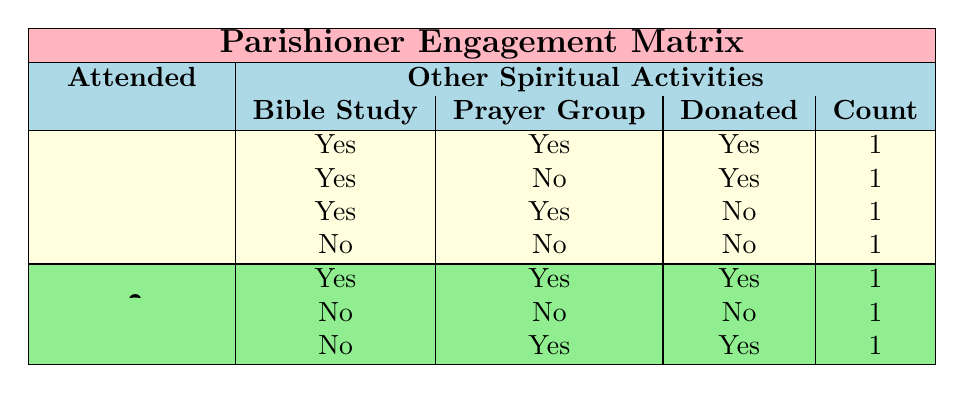What is the total number of parishioners who attended online mass? By looking at the table, I count 4 entries (1, 2, 5, and 6) under the "Yes" category for attended online mass, indicating that there are 4 parishioners who attended online mass.
Answer: 4 How many parishioners engaged in both Bible study and the online prayer group? In the "Yes" category for attended online mass, there are 3 rows (1, 3, and 5) where parishioners participated in Bible study and engaged in the online prayer group. Also, parishioner 6 also engaged in both these activities, making a total of 4.
Answer: 4 Did any parishioner not donate after attending online mass? Upon examining the table, I see that there is 1 parishioner (6) who attended online mass but did not donate, which answers the question with a yes.
Answer: Yes What is the count of parishioners who did not attend online mass and participated in some other spiritual activities? Looking at the "No" category for attended online mass, I see that 1 parishioner participated in Bible study and the prayer group (7), while 1 has not participated in any activities (4), resulting in a count of 2 parishioners.
Answer: 2 Which spiritual activities were most commonly engaged in by parishioners who attended online mass? In the rows where parishioners attended online mass, 3 participated in Bible study and 2 engaged in online prayer groups. Therefore, Bible study was the most common activity among them with 3 participants.
Answer: Bible study How many parishioners have both engaged in online prayer groups and made donations? From the table, I find that 2 parishioners engaged in online prayer groups and also donated (1 and 7), while 1 participated in these activities without donating. Therefore, the total number who both engaged and donated is 2.
Answer: 2 Did more parishioners who did not attend online mass contribute compared to those who did? In the table, only 2 parishioners did not attend online mass but donated (6 and 7), while there were 3 parishioners who attended online mass and donated (1, 5, and 6). Thus, more who attended online mass contributed.
Answer: No What percentage of those who attended online mass participated in Bible study? There are 4 parishioners who attended online mass, and from them, 3 took part in Bible study. Therefore, the percentage is calculated as (3 / 4) × 100 = 75%.
Answer: 75% 